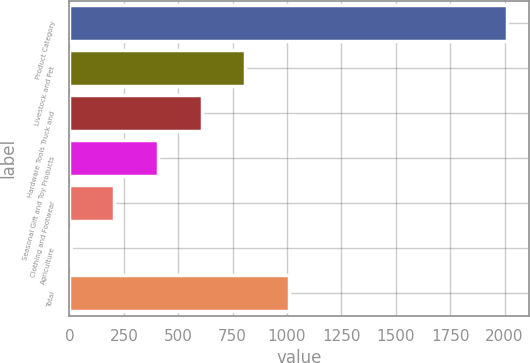Convert chart to OTSL. <chart><loc_0><loc_0><loc_500><loc_500><bar_chart><fcel>Product Category<fcel>Livestock and Pet<fcel>Hardware Tools Truck and<fcel>Seasonal Gift and Toy Products<fcel>Clothing and Footwear<fcel>Agriculture<fcel>Total<nl><fcel>2012<fcel>808.4<fcel>607.8<fcel>407.2<fcel>206.6<fcel>6<fcel>1009<nl></chart> 